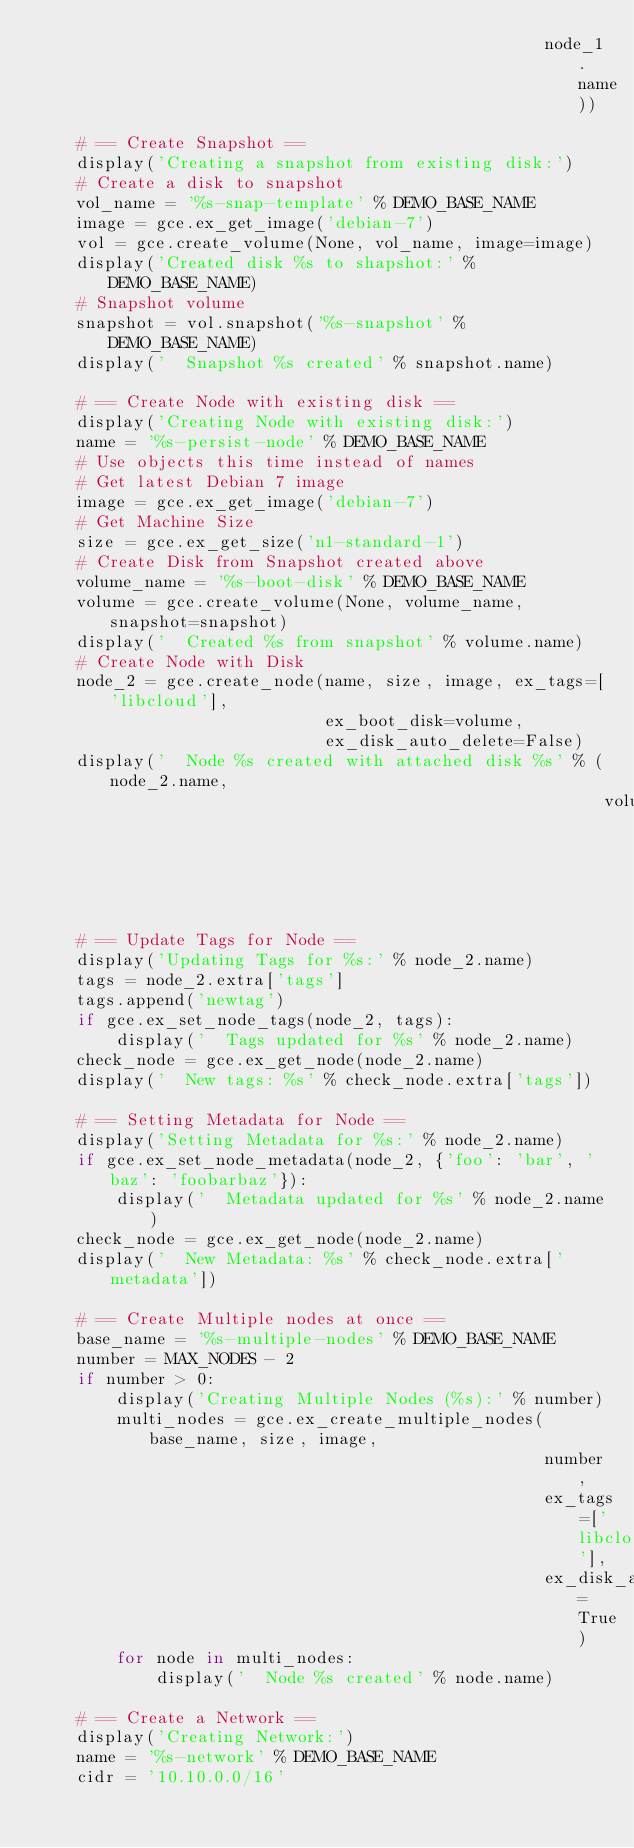<code> <loc_0><loc_0><loc_500><loc_500><_Python_>                                                   node_1.name))

    # == Create Snapshot ==
    display('Creating a snapshot from existing disk:')
    # Create a disk to snapshot
    vol_name = '%s-snap-template' % DEMO_BASE_NAME
    image = gce.ex_get_image('debian-7')
    vol = gce.create_volume(None, vol_name, image=image)
    display('Created disk %s to shapshot:' % DEMO_BASE_NAME)
    # Snapshot volume
    snapshot = vol.snapshot('%s-snapshot' % DEMO_BASE_NAME)
    display('  Snapshot %s created' % snapshot.name)

    # == Create Node with existing disk ==
    display('Creating Node with existing disk:')
    name = '%s-persist-node' % DEMO_BASE_NAME
    # Use objects this time instead of names
    # Get latest Debian 7 image
    image = gce.ex_get_image('debian-7')
    # Get Machine Size
    size = gce.ex_get_size('n1-standard-1')
    # Create Disk from Snapshot created above
    volume_name = '%s-boot-disk' % DEMO_BASE_NAME
    volume = gce.create_volume(None, volume_name, snapshot=snapshot)
    display('  Created %s from snapshot' % volume.name)
    # Create Node with Disk
    node_2 = gce.create_node(name, size, image, ex_tags=['libcloud'],
                             ex_boot_disk=volume,
                             ex_disk_auto_delete=False)
    display('  Node %s created with attached disk %s' % (node_2.name,
                                                         volume.name))

    # == Update Tags for Node ==
    display('Updating Tags for %s:' % node_2.name)
    tags = node_2.extra['tags']
    tags.append('newtag')
    if gce.ex_set_node_tags(node_2, tags):
        display('  Tags updated for %s' % node_2.name)
    check_node = gce.ex_get_node(node_2.name)
    display('  New tags: %s' % check_node.extra['tags'])

    # == Setting Metadata for Node ==
    display('Setting Metadata for %s:' % node_2.name)
    if gce.ex_set_node_metadata(node_2, {'foo': 'bar', 'baz': 'foobarbaz'}):
        display('  Metadata updated for %s' % node_2.name)
    check_node = gce.ex_get_node(node_2.name)
    display('  New Metadata: %s' % check_node.extra['metadata'])

    # == Create Multiple nodes at once ==
    base_name = '%s-multiple-nodes' % DEMO_BASE_NAME
    number = MAX_NODES - 2
    if number > 0:
        display('Creating Multiple Nodes (%s):' % number)
        multi_nodes = gce.ex_create_multiple_nodes(base_name, size, image,
                                                   number,
                                                   ex_tags=['libcloud'],
                                                   ex_disk_auto_delete=True)
        for node in multi_nodes:
            display('  Node %s created' % node.name)

    # == Create a Network ==
    display('Creating Network:')
    name = '%s-network' % DEMO_BASE_NAME
    cidr = '10.10.0.0/16'</code> 